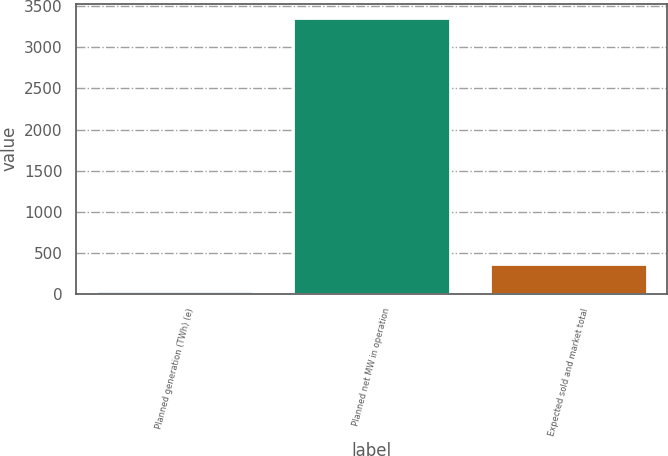Convert chart to OTSL. <chart><loc_0><loc_0><loc_500><loc_500><bar_chart><fcel>Planned generation (TWh) (e)<fcel>Planned net MW in operation<fcel>Expected sold and market total<nl><fcel>26.7<fcel>3365<fcel>360.53<nl></chart> 